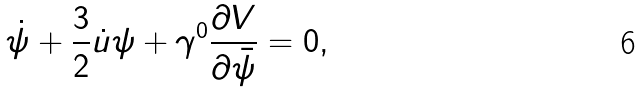Convert formula to latex. <formula><loc_0><loc_0><loc_500><loc_500>\dot { \psi } + \frac { 3 } { 2 } \dot { u } \psi + \gamma ^ { 0 } \frac { \partial V } { \partial \bar { \psi } } = 0 ,</formula> 